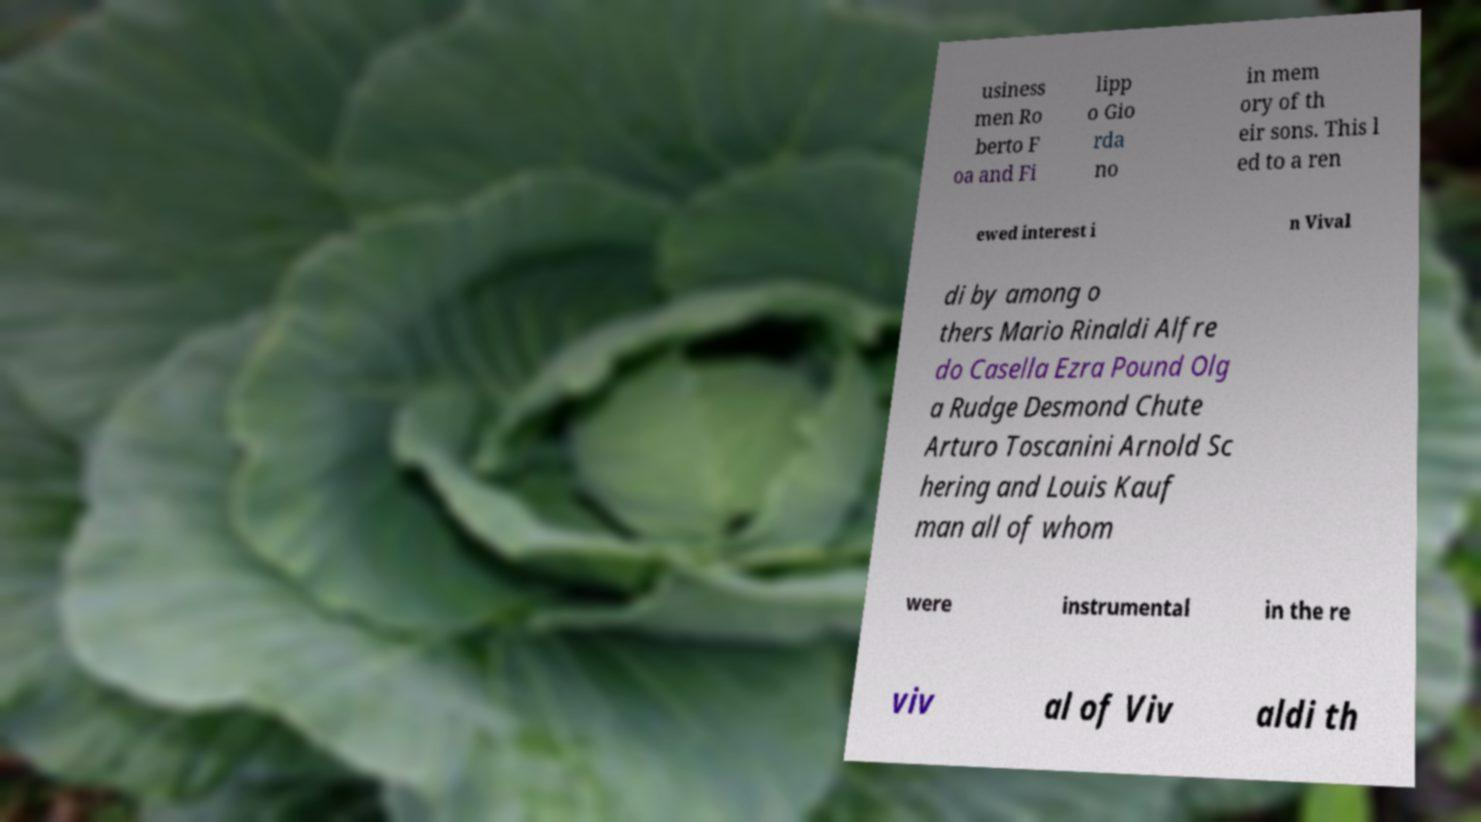Please identify and transcribe the text found in this image. usiness men Ro berto F oa and Fi lipp o Gio rda no in mem ory of th eir sons. This l ed to a ren ewed interest i n Vival di by among o thers Mario Rinaldi Alfre do Casella Ezra Pound Olg a Rudge Desmond Chute Arturo Toscanini Arnold Sc hering and Louis Kauf man all of whom were instrumental in the re viv al of Viv aldi th 